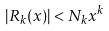Convert formula to latex. <formula><loc_0><loc_0><loc_500><loc_500>| R _ { k } ( x ) | < N _ { k } x ^ { k }</formula> 